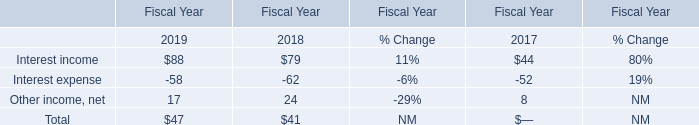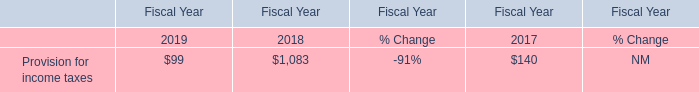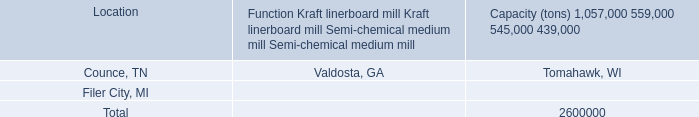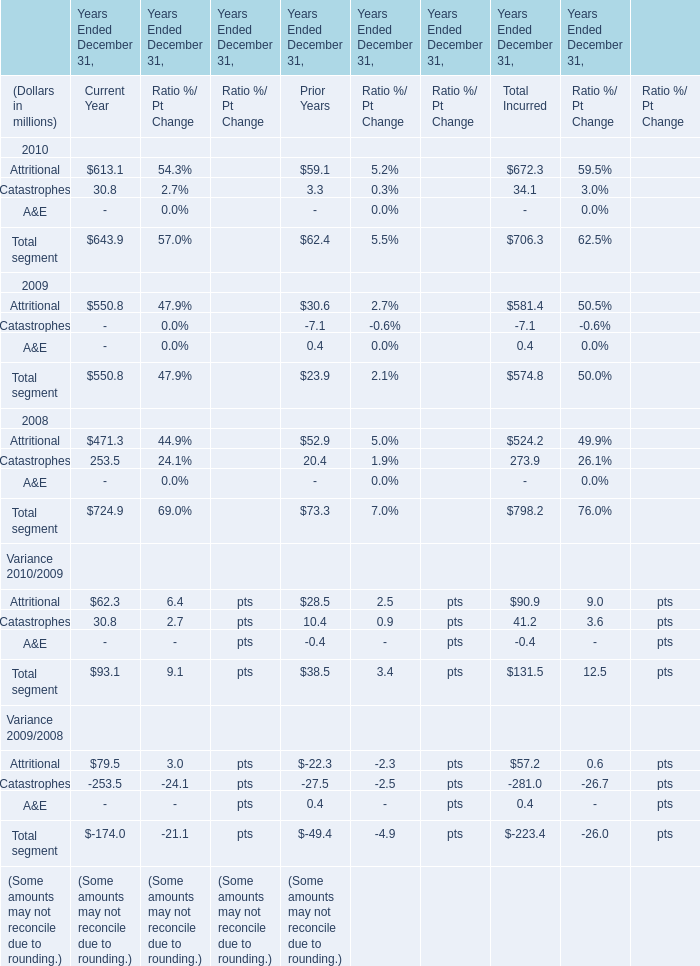In the year with largest amount of total segment for total incurred, what's the sum of segment? (in million) 
Computations: (524.2 + 273.9)
Answer: 798.1. 